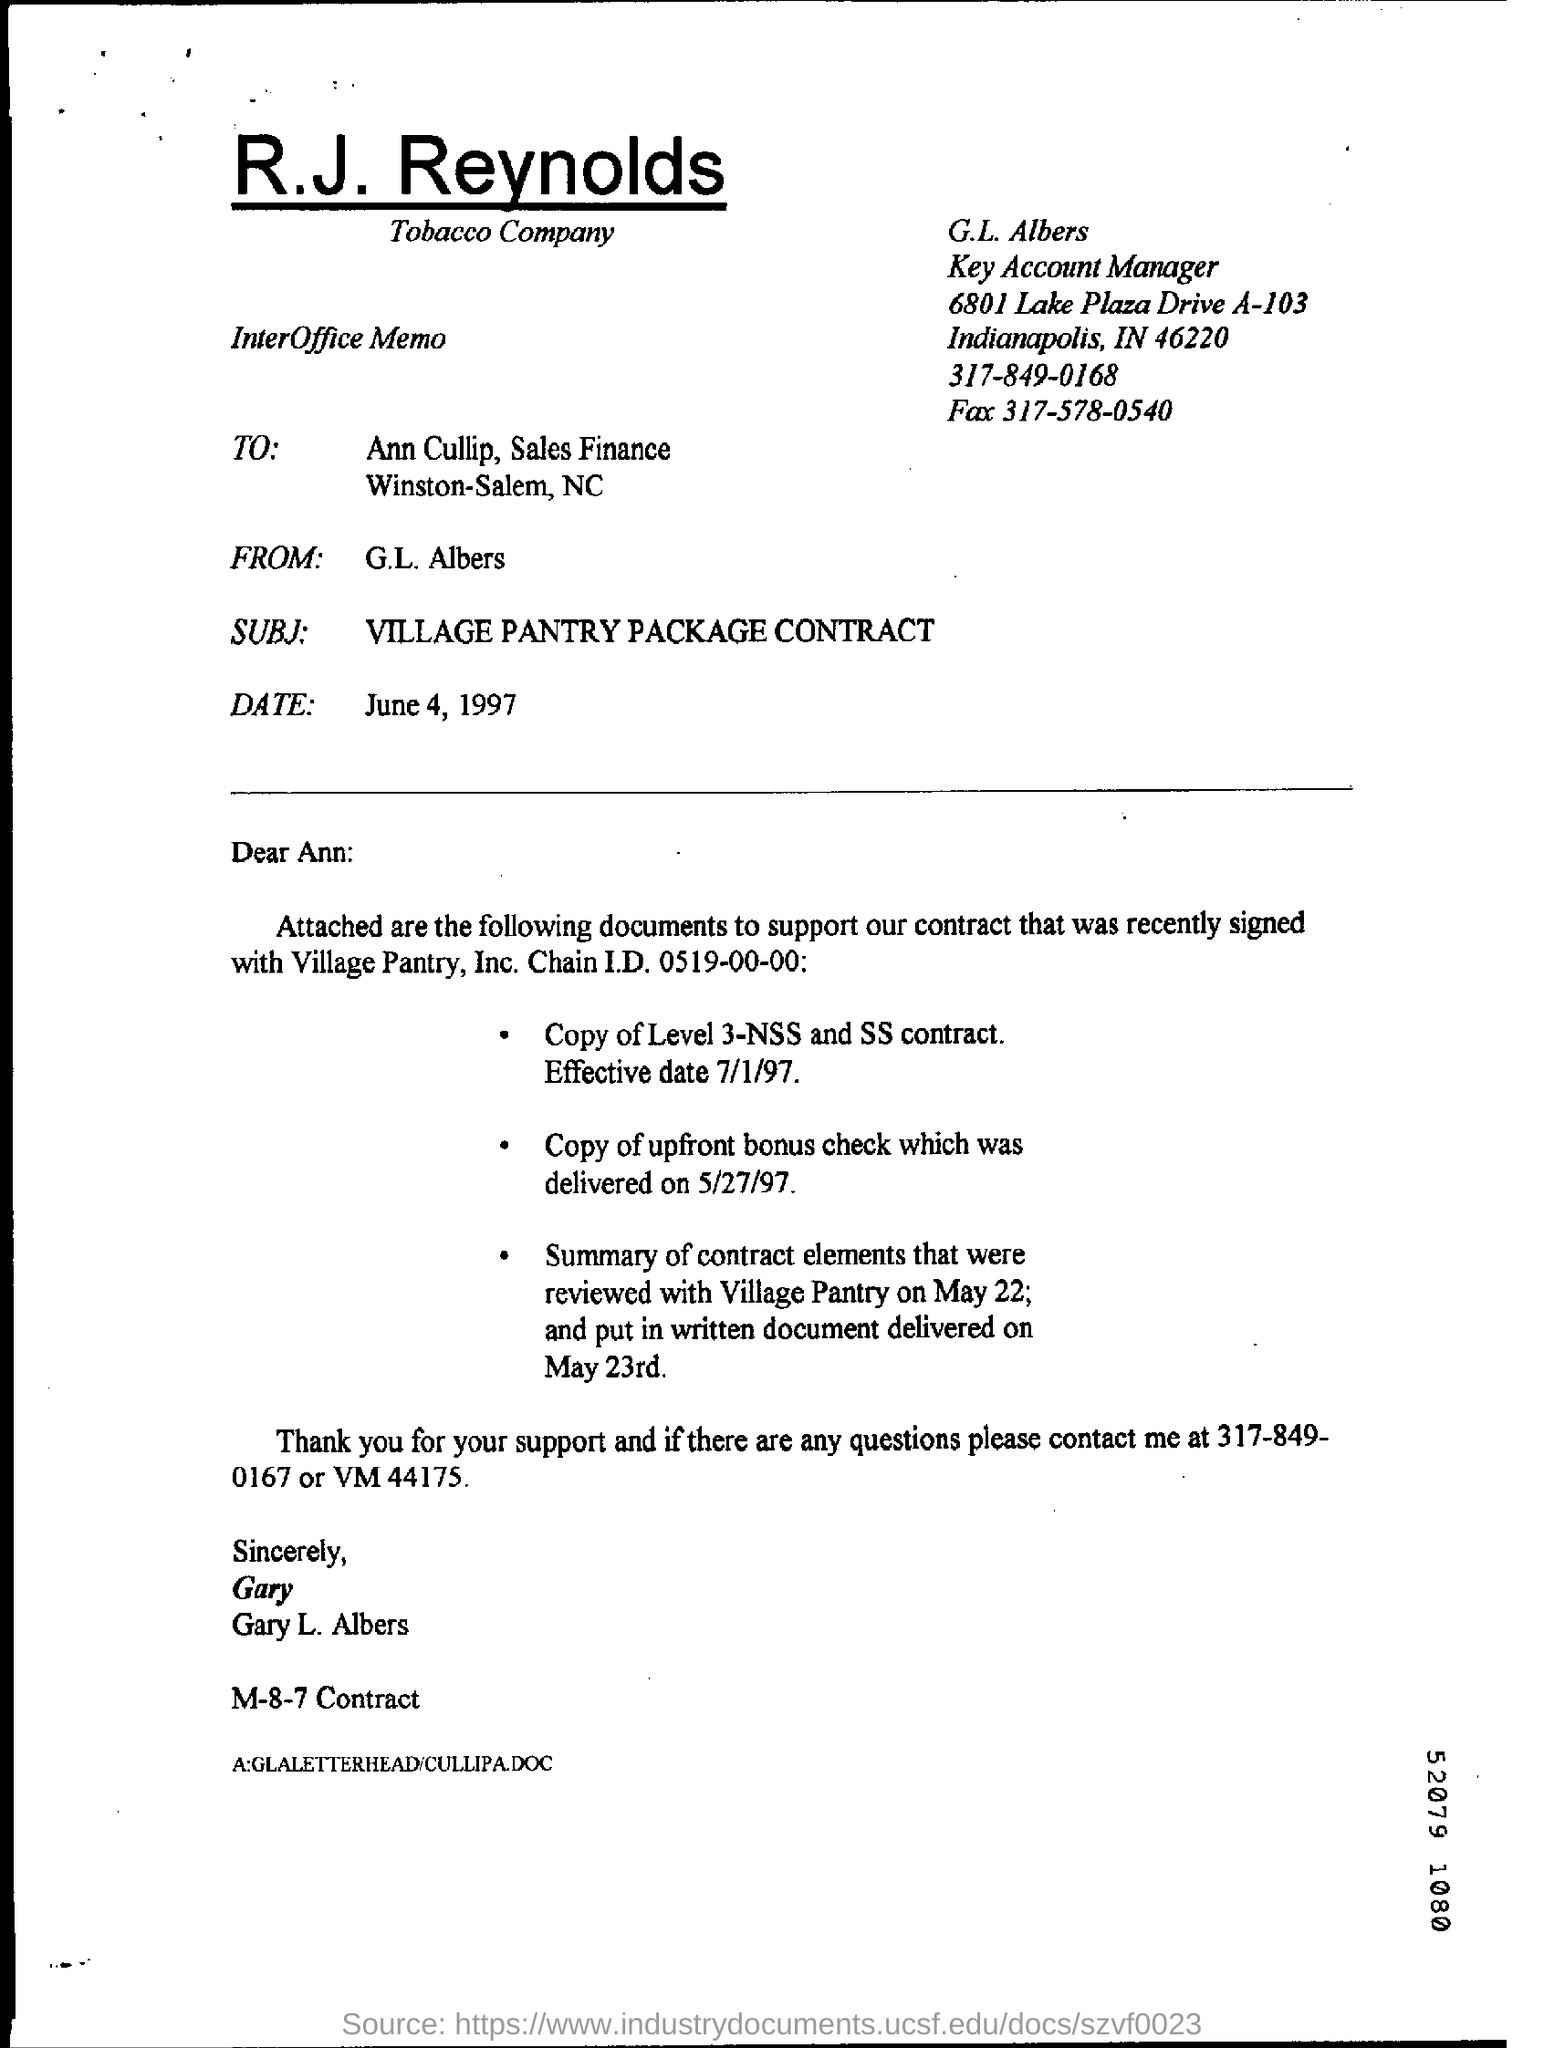Identify some key points in this picture. The street address of G.L Albers is located at 6801 Lake Plaza Drive A-103. The date of the interoffice memo is June 4, 1997. G.L. Albers is the key account manager, holding the position of. 